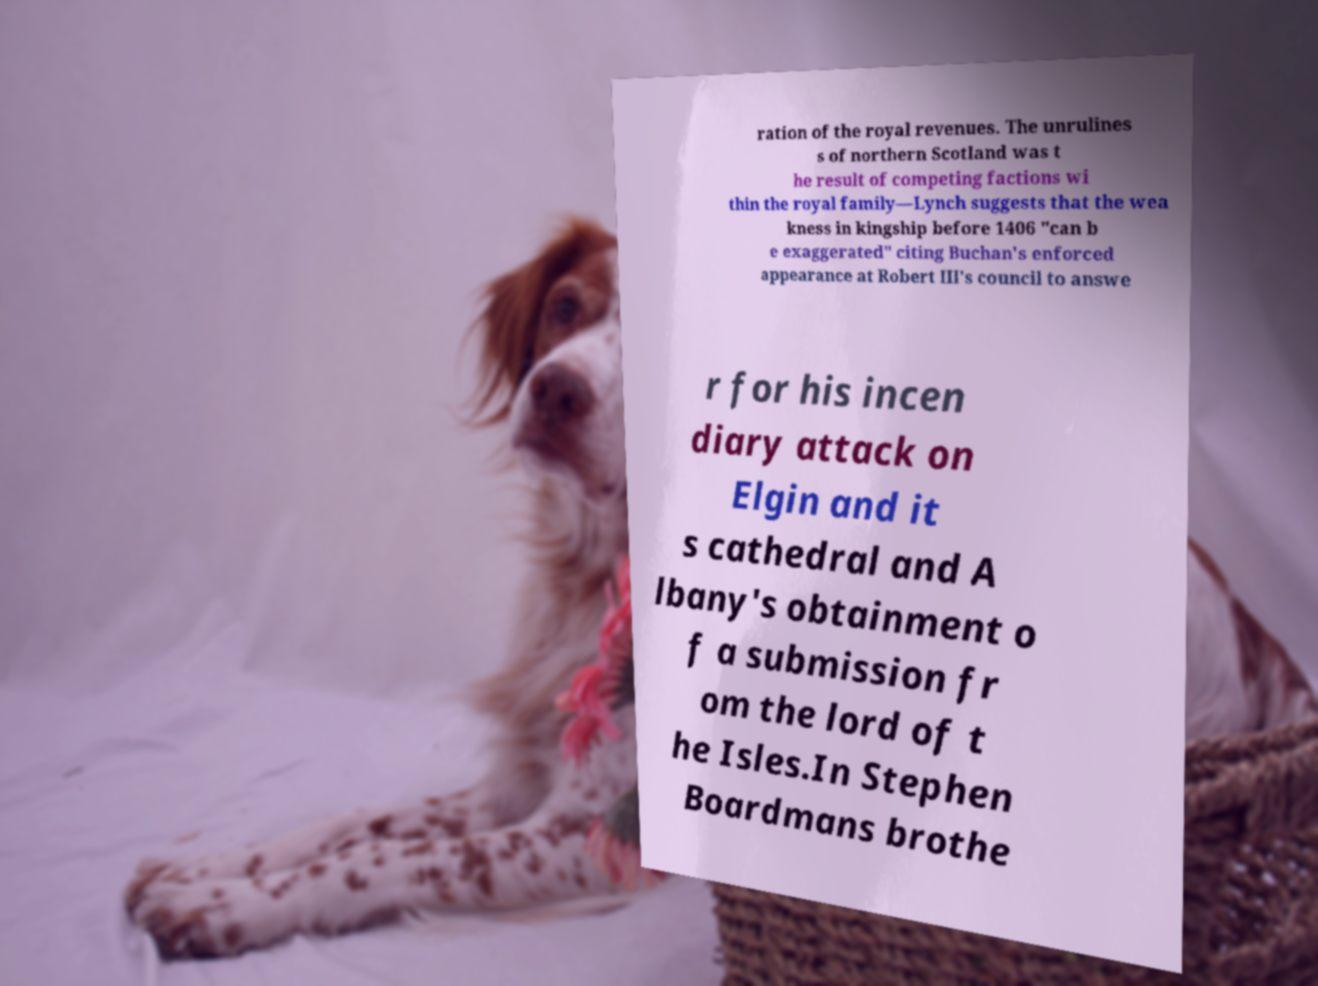Could you extract and type out the text from this image? ration of the royal revenues. The unrulines s of northern Scotland was t he result of competing factions wi thin the royal family—Lynch suggests that the wea kness in kingship before 1406 "can b e exaggerated" citing Buchan's enforced appearance at Robert III's council to answe r for his incen diary attack on Elgin and it s cathedral and A lbany's obtainment o f a submission fr om the lord of t he Isles.In Stephen Boardmans brothe 